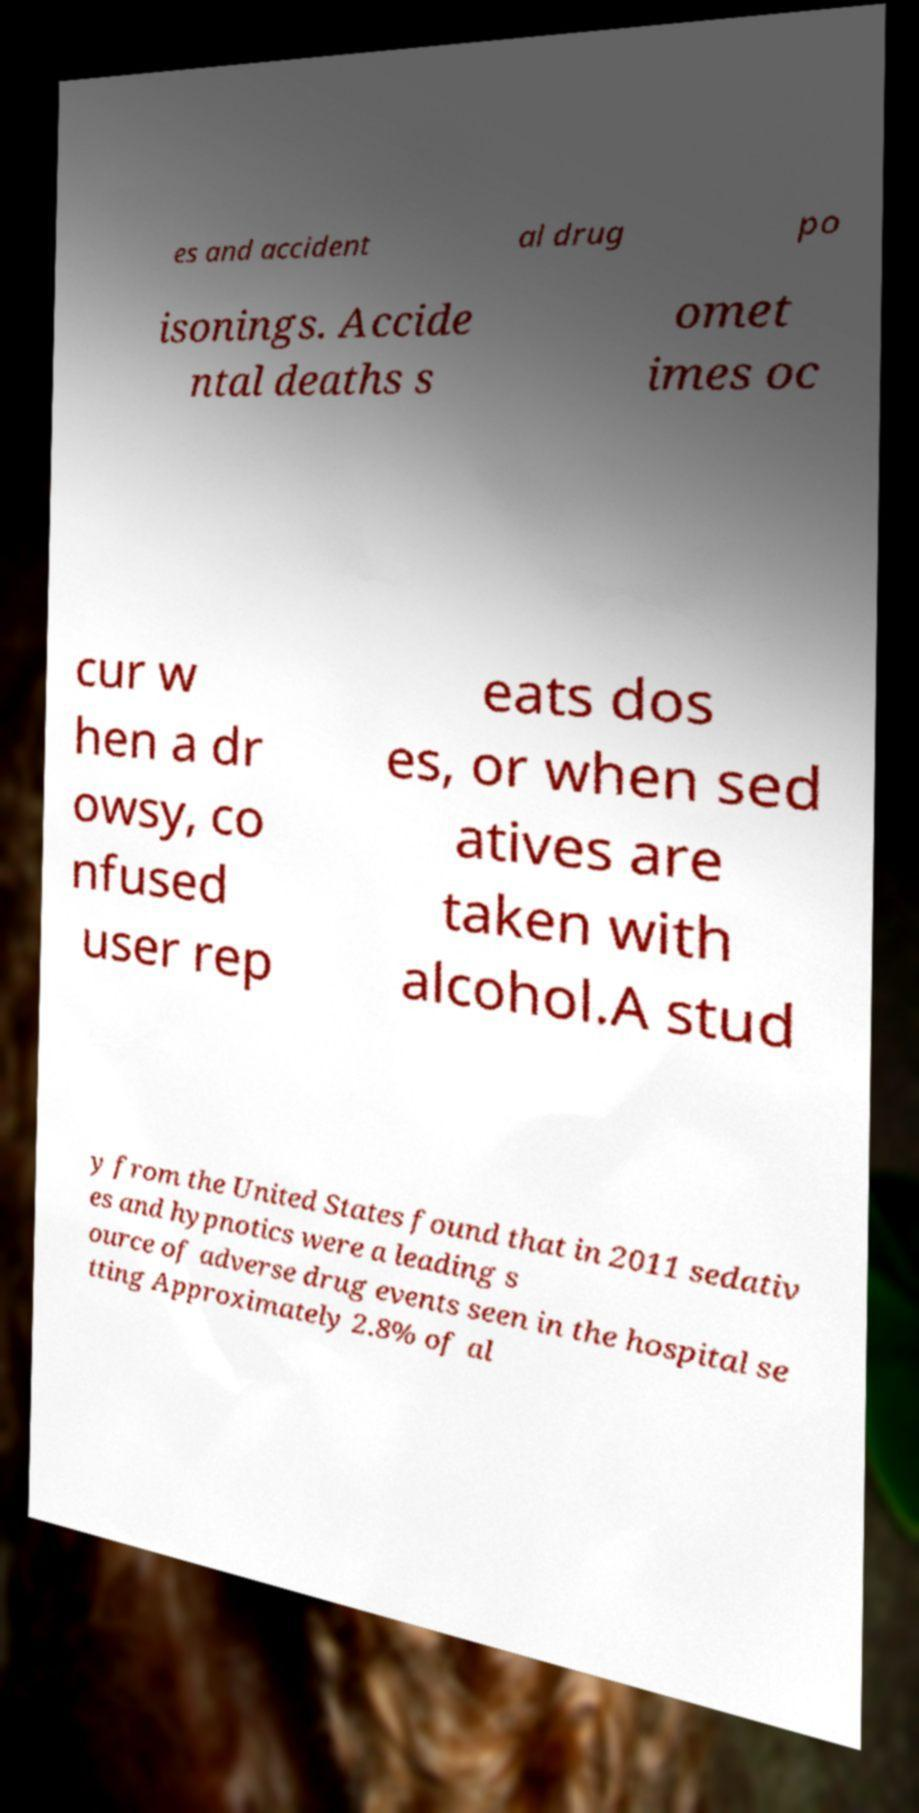For documentation purposes, I need the text within this image transcribed. Could you provide that? es and accident al drug po isonings. Accide ntal deaths s omet imes oc cur w hen a dr owsy, co nfused user rep eats dos es, or when sed atives are taken with alcohol.A stud y from the United States found that in 2011 sedativ es and hypnotics were a leading s ource of adverse drug events seen in the hospital se tting Approximately 2.8% of al 